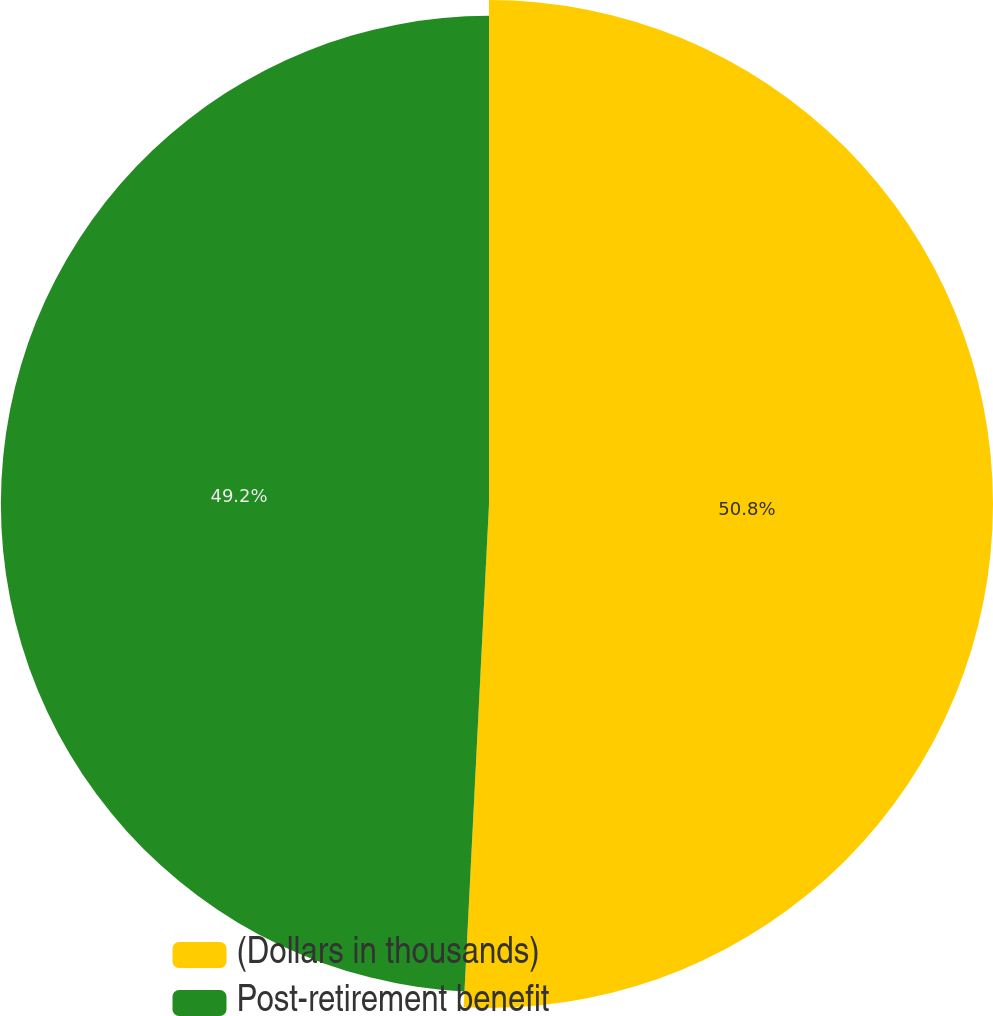<chart> <loc_0><loc_0><loc_500><loc_500><pie_chart><fcel>(Dollars in thousands)<fcel>Post-retirement benefit<nl><fcel>50.8%<fcel>49.2%<nl></chart> 